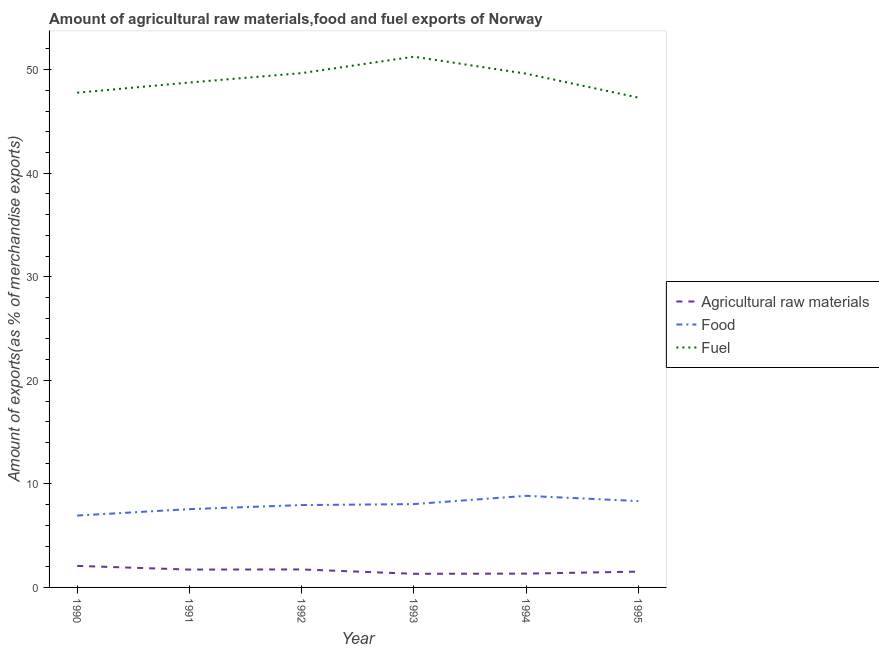Does the line corresponding to percentage of fuel exports intersect with the line corresponding to percentage of food exports?
Ensure brevity in your answer.  No. Is the number of lines equal to the number of legend labels?
Your response must be concise. Yes. What is the percentage of raw materials exports in 1991?
Your answer should be very brief. 1.72. Across all years, what is the maximum percentage of fuel exports?
Your answer should be very brief. 51.26. Across all years, what is the minimum percentage of food exports?
Offer a very short reply. 6.94. In which year was the percentage of food exports maximum?
Offer a terse response. 1994. What is the total percentage of fuel exports in the graph?
Ensure brevity in your answer.  294.38. What is the difference between the percentage of fuel exports in 1991 and that in 1994?
Ensure brevity in your answer.  -0.85. What is the difference between the percentage of food exports in 1990 and the percentage of fuel exports in 1994?
Offer a terse response. -42.67. What is the average percentage of raw materials exports per year?
Your answer should be very brief. 1.62. In the year 1993, what is the difference between the percentage of food exports and percentage of fuel exports?
Give a very brief answer. -43.21. In how many years, is the percentage of food exports greater than 20 %?
Your answer should be compact. 0. What is the ratio of the percentage of food exports in 1993 to that in 1995?
Provide a short and direct response. 0.96. What is the difference between the highest and the second highest percentage of food exports?
Your answer should be compact. 0.5. What is the difference between the highest and the lowest percentage of fuel exports?
Ensure brevity in your answer.  3.95. Is the percentage of food exports strictly greater than the percentage of fuel exports over the years?
Provide a succinct answer. No. Is the percentage of raw materials exports strictly less than the percentage of fuel exports over the years?
Provide a succinct answer. Yes. How many years are there in the graph?
Give a very brief answer. 6. Does the graph contain any zero values?
Give a very brief answer. No. Where does the legend appear in the graph?
Provide a short and direct response. Center right. How many legend labels are there?
Make the answer very short. 3. What is the title of the graph?
Give a very brief answer. Amount of agricultural raw materials,food and fuel exports of Norway. What is the label or title of the X-axis?
Your answer should be very brief. Year. What is the label or title of the Y-axis?
Provide a short and direct response. Amount of exports(as % of merchandise exports). What is the Amount of exports(as % of merchandise exports) in Agricultural raw materials in 1990?
Ensure brevity in your answer.  2.08. What is the Amount of exports(as % of merchandise exports) in Food in 1990?
Make the answer very short. 6.94. What is the Amount of exports(as % of merchandise exports) in Fuel in 1990?
Give a very brief answer. 47.78. What is the Amount of exports(as % of merchandise exports) in Agricultural raw materials in 1991?
Offer a very short reply. 1.72. What is the Amount of exports(as % of merchandise exports) in Food in 1991?
Your answer should be compact. 7.56. What is the Amount of exports(as % of merchandise exports) of Fuel in 1991?
Offer a terse response. 48.76. What is the Amount of exports(as % of merchandise exports) of Agricultural raw materials in 1992?
Your answer should be very brief. 1.74. What is the Amount of exports(as % of merchandise exports) in Food in 1992?
Provide a short and direct response. 7.95. What is the Amount of exports(as % of merchandise exports) in Fuel in 1992?
Provide a short and direct response. 49.67. What is the Amount of exports(as % of merchandise exports) in Agricultural raw materials in 1993?
Provide a short and direct response. 1.32. What is the Amount of exports(as % of merchandise exports) of Food in 1993?
Keep it short and to the point. 8.05. What is the Amount of exports(as % of merchandise exports) of Fuel in 1993?
Your answer should be compact. 51.26. What is the Amount of exports(as % of merchandise exports) in Agricultural raw materials in 1994?
Give a very brief answer. 1.33. What is the Amount of exports(as % of merchandise exports) in Food in 1994?
Provide a short and direct response. 8.85. What is the Amount of exports(as % of merchandise exports) of Fuel in 1994?
Offer a very short reply. 49.62. What is the Amount of exports(as % of merchandise exports) of Agricultural raw materials in 1995?
Offer a terse response. 1.53. What is the Amount of exports(as % of merchandise exports) of Food in 1995?
Provide a succinct answer. 8.34. What is the Amount of exports(as % of merchandise exports) of Fuel in 1995?
Offer a terse response. 47.3. Across all years, what is the maximum Amount of exports(as % of merchandise exports) of Agricultural raw materials?
Your response must be concise. 2.08. Across all years, what is the maximum Amount of exports(as % of merchandise exports) in Food?
Offer a terse response. 8.85. Across all years, what is the maximum Amount of exports(as % of merchandise exports) of Fuel?
Offer a terse response. 51.26. Across all years, what is the minimum Amount of exports(as % of merchandise exports) in Agricultural raw materials?
Ensure brevity in your answer.  1.32. Across all years, what is the minimum Amount of exports(as % of merchandise exports) of Food?
Offer a very short reply. 6.94. Across all years, what is the minimum Amount of exports(as % of merchandise exports) of Fuel?
Your answer should be compact. 47.3. What is the total Amount of exports(as % of merchandise exports) in Agricultural raw materials in the graph?
Offer a terse response. 9.72. What is the total Amount of exports(as % of merchandise exports) of Food in the graph?
Your response must be concise. 47.69. What is the total Amount of exports(as % of merchandise exports) of Fuel in the graph?
Make the answer very short. 294.38. What is the difference between the Amount of exports(as % of merchandise exports) of Agricultural raw materials in 1990 and that in 1991?
Keep it short and to the point. 0.36. What is the difference between the Amount of exports(as % of merchandise exports) of Food in 1990 and that in 1991?
Give a very brief answer. -0.62. What is the difference between the Amount of exports(as % of merchandise exports) of Fuel in 1990 and that in 1991?
Provide a succinct answer. -0.98. What is the difference between the Amount of exports(as % of merchandise exports) of Agricultural raw materials in 1990 and that in 1992?
Keep it short and to the point. 0.34. What is the difference between the Amount of exports(as % of merchandise exports) of Food in 1990 and that in 1992?
Your answer should be compact. -1.01. What is the difference between the Amount of exports(as % of merchandise exports) of Fuel in 1990 and that in 1992?
Your answer should be very brief. -1.89. What is the difference between the Amount of exports(as % of merchandise exports) of Agricultural raw materials in 1990 and that in 1993?
Provide a succinct answer. 0.76. What is the difference between the Amount of exports(as % of merchandise exports) in Food in 1990 and that in 1993?
Offer a terse response. -1.1. What is the difference between the Amount of exports(as % of merchandise exports) in Fuel in 1990 and that in 1993?
Your answer should be very brief. -3.48. What is the difference between the Amount of exports(as % of merchandise exports) of Agricultural raw materials in 1990 and that in 1994?
Offer a very short reply. 0.75. What is the difference between the Amount of exports(as % of merchandise exports) in Food in 1990 and that in 1994?
Offer a very short reply. -1.9. What is the difference between the Amount of exports(as % of merchandise exports) of Fuel in 1990 and that in 1994?
Keep it short and to the point. -1.84. What is the difference between the Amount of exports(as % of merchandise exports) of Agricultural raw materials in 1990 and that in 1995?
Offer a very short reply. 0.55. What is the difference between the Amount of exports(as % of merchandise exports) in Food in 1990 and that in 1995?
Make the answer very short. -1.4. What is the difference between the Amount of exports(as % of merchandise exports) of Fuel in 1990 and that in 1995?
Keep it short and to the point. 0.47. What is the difference between the Amount of exports(as % of merchandise exports) in Agricultural raw materials in 1991 and that in 1992?
Make the answer very short. -0.01. What is the difference between the Amount of exports(as % of merchandise exports) in Food in 1991 and that in 1992?
Make the answer very short. -0.39. What is the difference between the Amount of exports(as % of merchandise exports) in Fuel in 1991 and that in 1992?
Your response must be concise. -0.91. What is the difference between the Amount of exports(as % of merchandise exports) of Agricultural raw materials in 1991 and that in 1993?
Your response must be concise. 0.41. What is the difference between the Amount of exports(as % of merchandise exports) of Food in 1991 and that in 1993?
Offer a terse response. -0.49. What is the difference between the Amount of exports(as % of merchandise exports) in Fuel in 1991 and that in 1993?
Provide a succinct answer. -2.5. What is the difference between the Amount of exports(as % of merchandise exports) of Agricultural raw materials in 1991 and that in 1994?
Keep it short and to the point. 0.39. What is the difference between the Amount of exports(as % of merchandise exports) in Food in 1991 and that in 1994?
Your response must be concise. -1.28. What is the difference between the Amount of exports(as % of merchandise exports) in Fuel in 1991 and that in 1994?
Offer a very short reply. -0.85. What is the difference between the Amount of exports(as % of merchandise exports) of Agricultural raw materials in 1991 and that in 1995?
Ensure brevity in your answer.  0.2. What is the difference between the Amount of exports(as % of merchandise exports) in Food in 1991 and that in 1995?
Offer a very short reply. -0.78. What is the difference between the Amount of exports(as % of merchandise exports) in Fuel in 1991 and that in 1995?
Your answer should be compact. 1.46. What is the difference between the Amount of exports(as % of merchandise exports) in Agricultural raw materials in 1992 and that in 1993?
Provide a short and direct response. 0.42. What is the difference between the Amount of exports(as % of merchandise exports) of Food in 1992 and that in 1993?
Your response must be concise. -0.1. What is the difference between the Amount of exports(as % of merchandise exports) of Fuel in 1992 and that in 1993?
Make the answer very short. -1.59. What is the difference between the Amount of exports(as % of merchandise exports) in Agricultural raw materials in 1992 and that in 1994?
Keep it short and to the point. 0.4. What is the difference between the Amount of exports(as % of merchandise exports) of Food in 1992 and that in 1994?
Ensure brevity in your answer.  -0.89. What is the difference between the Amount of exports(as % of merchandise exports) of Fuel in 1992 and that in 1994?
Keep it short and to the point. 0.05. What is the difference between the Amount of exports(as % of merchandise exports) of Agricultural raw materials in 1992 and that in 1995?
Offer a very short reply. 0.21. What is the difference between the Amount of exports(as % of merchandise exports) of Food in 1992 and that in 1995?
Provide a short and direct response. -0.39. What is the difference between the Amount of exports(as % of merchandise exports) in Fuel in 1992 and that in 1995?
Offer a very short reply. 2.36. What is the difference between the Amount of exports(as % of merchandise exports) of Agricultural raw materials in 1993 and that in 1994?
Make the answer very short. -0.02. What is the difference between the Amount of exports(as % of merchandise exports) of Food in 1993 and that in 1994?
Your answer should be compact. -0.8. What is the difference between the Amount of exports(as % of merchandise exports) in Fuel in 1993 and that in 1994?
Give a very brief answer. 1.64. What is the difference between the Amount of exports(as % of merchandise exports) in Agricultural raw materials in 1993 and that in 1995?
Ensure brevity in your answer.  -0.21. What is the difference between the Amount of exports(as % of merchandise exports) of Food in 1993 and that in 1995?
Provide a short and direct response. -0.29. What is the difference between the Amount of exports(as % of merchandise exports) of Fuel in 1993 and that in 1995?
Offer a terse response. 3.95. What is the difference between the Amount of exports(as % of merchandise exports) in Agricultural raw materials in 1994 and that in 1995?
Give a very brief answer. -0.19. What is the difference between the Amount of exports(as % of merchandise exports) in Food in 1994 and that in 1995?
Ensure brevity in your answer.  0.5. What is the difference between the Amount of exports(as % of merchandise exports) in Fuel in 1994 and that in 1995?
Your answer should be compact. 2.31. What is the difference between the Amount of exports(as % of merchandise exports) in Agricultural raw materials in 1990 and the Amount of exports(as % of merchandise exports) in Food in 1991?
Your answer should be very brief. -5.48. What is the difference between the Amount of exports(as % of merchandise exports) in Agricultural raw materials in 1990 and the Amount of exports(as % of merchandise exports) in Fuel in 1991?
Provide a succinct answer. -46.68. What is the difference between the Amount of exports(as % of merchandise exports) of Food in 1990 and the Amount of exports(as % of merchandise exports) of Fuel in 1991?
Your answer should be very brief. -41.82. What is the difference between the Amount of exports(as % of merchandise exports) in Agricultural raw materials in 1990 and the Amount of exports(as % of merchandise exports) in Food in 1992?
Your answer should be compact. -5.87. What is the difference between the Amount of exports(as % of merchandise exports) in Agricultural raw materials in 1990 and the Amount of exports(as % of merchandise exports) in Fuel in 1992?
Your answer should be very brief. -47.59. What is the difference between the Amount of exports(as % of merchandise exports) in Food in 1990 and the Amount of exports(as % of merchandise exports) in Fuel in 1992?
Keep it short and to the point. -42.73. What is the difference between the Amount of exports(as % of merchandise exports) of Agricultural raw materials in 1990 and the Amount of exports(as % of merchandise exports) of Food in 1993?
Offer a very short reply. -5.97. What is the difference between the Amount of exports(as % of merchandise exports) of Agricultural raw materials in 1990 and the Amount of exports(as % of merchandise exports) of Fuel in 1993?
Keep it short and to the point. -49.18. What is the difference between the Amount of exports(as % of merchandise exports) of Food in 1990 and the Amount of exports(as % of merchandise exports) of Fuel in 1993?
Give a very brief answer. -44.31. What is the difference between the Amount of exports(as % of merchandise exports) in Agricultural raw materials in 1990 and the Amount of exports(as % of merchandise exports) in Food in 1994?
Offer a terse response. -6.77. What is the difference between the Amount of exports(as % of merchandise exports) in Agricultural raw materials in 1990 and the Amount of exports(as % of merchandise exports) in Fuel in 1994?
Keep it short and to the point. -47.54. What is the difference between the Amount of exports(as % of merchandise exports) in Food in 1990 and the Amount of exports(as % of merchandise exports) in Fuel in 1994?
Provide a succinct answer. -42.67. What is the difference between the Amount of exports(as % of merchandise exports) of Agricultural raw materials in 1990 and the Amount of exports(as % of merchandise exports) of Food in 1995?
Your response must be concise. -6.26. What is the difference between the Amount of exports(as % of merchandise exports) of Agricultural raw materials in 1990 and the Amount of exports(as % of merchandise exports) of Fuel in 1995?
Offer a terse response. -45.22. What is the difference between the Amount of exports(as % of merchandise exports) of Food in 1990 and the Amount of exports(as % of merchandise exports) of Fuel in 1995?
Your answer should be compact. -40.36. What is the difference between the Amount of exports(as % of merchandise exports) of Agricultural raw materials in 1991 and the Amount of exports(as % of merchandise exports) of Food in 1992?
Make the answer very short. -6.23. What is the difference between the Amount of exports(as % of merchandise exports) of Agricultural raw materials in 1991 and the Amount of exports(as % of merchandise exports) of Fuel in 1992?
Provide a short and direct response. -47.95. What is the difference between the Amount of exports(as % of merchandise exports) of Food in 1991 and the Amount of exports(as % of merchandise exports) of Fuel in 1992?
Keep it short and to the point. -42.11. What is the difference between the Amount of exports(as % of merchandise exports) of Agricultural raw materials in 1991 and the Amount of exports(as % of merchandise exports) of Food in 1993?
Provide a succinct answer. -6.32. What is the difference between the Amount of exports(as % of merchandise exports) in Agricultural raw materials in 1991 and the Amount of exports(as % of merchandise exports) in Fuel in 1993?
Provide a short and direct response. -49.53. What is the difference between the Amount of exports(as % of merchandise exports) of Food in 1991 and the Amount of exports(as % of merchandise exports) of Fuel in 1993?
Offer a very short reply. -43.69. What is the difference between the Amount of exports(as % of merchandise exports) of Agricultural raw materials in 1991 and the Amount of exports(as % of merchandise exports) of Food in 1994?
Your answer should be very brief. -7.12. What is the difference between the Amount of exports(as % of merchandise exports) of Agricultural raw materials in 1991 and the Amount of exports(as % of merchandise exports) of Fuel in 1994?
Ensure brevity in your answer.  -47.89. What is the difference between the Amount of exports(as % of merchandise exports) of Food in 1991 and the Amount of exports(as % of merchandise exports) of Fuel in 1994?
Your answer should be compact. -42.05. What is the difference between the Amount of exports(as % of merchandise exports) in Agricultural raw materials in 1991 and the Amount of exports(as % of merchandise exports) in Food in 1995?
Make the answer very short. -6.62. What is the difference between the Amount of exports(as % of merchandise exports) in Agricultural raw materials in 1991 and the Amount of exports(as % of merchandise exports) in Fuel in 1995?
Provide a short and direct response. -45.58. What is the difference between the Amount of exports(as % of merchandise exports) of Food in 1991 and the Amount of exports(as % of merchandise exports) of Fuel in 1995?
Provide a short and direct response. -39.74. What is the difference between the Amount of exports(as % of merchandise exports) in Agricultural raw materials in 1992 and the Amount of exports(as % of merchandise exports) in Food in 1993?
Keep it short and to the point. -6.31. What is the difference between the Amount of exports(as % of merchandise exports) of Agricultural raw materials in 1992 and the Amount of exports(as % of merchandise exports) of Fuel in 1993?
Your answer should be very brief. -49.52. What is the difference between the Amount of exports(as % of merchandise exports) of Food in 1992 and the Amount of exports(as % of merchandise exports) of Fuel in 1993?
Your answer should be very brief. -43.3. What is the difference between the Amount of exports(as % of merchandise exports) of Agricultural raw materials in 1992 and the Amount of exports(as % of merchandise exports) of Food in 1994?
Offer a very short reply. -7.11. What is the difference between the Amount of exports(as % of merchandise exports) in Agricultural raw materials in 1992 and the Amount of exports(as % of merchandise exports) in Fuel in 1994?
Offer a terse response. -47.88. What is the difference between the Amount of exports(as % of merchandise exports) of Food in 1992 and the Amount of exports(as % of merchandise exports) of Fuel in 1994?
Offer a very short reply. -41.66. What is the difference between the Amount of exports(as % of merchandise exports) in Agricultural raw materials in 1992 and the Amount of exports(as % of merchandise exports) in Food in 1995?
Provide a succinct answer. -6.6. What is the difference between the Amount of exports(as % of merchandise exports) in Agricultural raw materials in 1992 and the Amount of exports(as % of merchandise exports) in Fuel in 1995?
Your answer should be very brief. -45.57. What is the difference between the Amount of exports(as % of merchandise exports) in Food in 1992 and the Amount of exports(as % of merchandise exports) in Fuel in 1995?
Give a very brief answer. -39.35. What is the difference between the Amount of exports(as % of merchandise exports) of Agricultural raw materials in 1993 and the Amount of exports(as % of merchandise exports) of Food in 1994?
Your response must be concise. -7.53. What is the difference between the Amount of exports(as % of merchandise exports) in Agricultural raw materials in 1993 and the Amount of exports(as % of merchandise exports) in Fuel in 1994?
Provide a short and direct response. -48.3. What is the difference between the Amount of exports(as % of merchandise exports) in Food in 1993 and the Amount of exports(as % of merchandise exports) in Fuel in 1994?
Make the answer very short. -41.57. What is the difference between the Amount of exports(as % of merchandise exports) in Agricultural raw materials in 1993 and the Amount of exports(as % of merchandise exports) in Food in 1995?
Your answer should be compact. -7.03. What is the difference between the Amount of exports(as % of merchandise exports) of Agricultural raw materials in 1993 and the Amount of exports(as % of merchandise exports) of Fuel in 1995?
Give a very brief answer. -45.99. What is the difference between the Amount of exports(as % of merchandise exports) in Food in 1993 and the Amount of exports(as % of merchandise exports) in Fuel in 1995?
Offer a terse response. -39.26. What is the difference between the Amount of exports(as % of merchandise exports) in Agricultural raw materials in 1994 and the Amount of exports(as % of merchandise exports) in Food in 1995?
Offer a very short reply. -7.01. What is the difference between the Amount of exports(as % of merchandise exports) in Agricultural raw materials in 1994 and the Amount of exports(as % of merchandise exports) in Fuel in 1995?
Keep it short and to the point. -45.97. What is the difference between the Amount of exports(as % of merchandise exports) in Food in 1994 and the Amount of exports(as % of merchandise exports) in Fuel in 1995?
Your response must be concise. -38.46. What is the average Amount of exports(as % of merchandise exports) of Agricultural raw materials per year?
Your response must be concise. 1.62. What is the average Amount of exports(as % of merchandise exports) in Food per year?
Your answer should be compact. 7.95. What is the average Amount of exports(as % of merchandise exports) in Fuel per year?
Your response must be concise. 49.06. In the year 1990, what is the difference between the Amount of exports(as % of merchandise exports) in Agricultural raw materials and Amount of exports(as % of merchandise exports) in Food?
Make the answer very short. -4.86. In the year 1990, what is the difference between the Amount of exports(as % of merchandise exports) in Agricultural raw materials and Amount of exports(as % of merchandise exports) in Fuel?
Ensure brevity in your answer.  -45.7. In the year 1990, what is the difference between the Amount of exports(as % of merchandise exports) of Food and Amount of exports(as % of merchandise exports) of Fuel?
Your answer should be very brief. -40.83. In the year 1991, what is the difference between the Amount of exports(as % of merchandise exports) in Agricultural raw materials and Amount of exports(as % of merchandise exports) in Food?
Keep it short and to the point. -5.84. In the year 1991, what is the difference between the Amount of exports(as % of merchandise exports) of Agricultural raw materials and Amount of exports(as % of merchandise exports) of Fuel?
Offer a very short reply. -47.04. In the year 1991, what is the difference between the Amount of exports(as % of merchandise exports) in Food and Amount of exports(as % of merchandise exports) in Fuel?
Offer a very short reply. -41.2. In the year 1992, what is the difference between the Amount of exports(as % of merchandise exports) in Agricultural raw materials and Amount of exports(as % of merchandise exports) in Food?
Give a very brief answer. -6.21. In the year 1992, what is the difference between the Amount of exports(as % of merchandise exports) of Agricultural raw materials and Amount of exports(as % of merchandise exports) of Fuel?
Ensure brevity in your answer.  -47.93. In the year 1992, what is the difference between the Amount of exports(as % of merchandise exports) of Food and Amount of exports(as % of merchandise exports) of Fuel?
Give a very brief answer. -41.72. In the year 1993, what is the difference between the Amount of exports(as % of merchandise exports) in Agricultural raw materials and Amount of exports(as % of merchandise exports) in Food?
Ensure brevity in your answer.  -6.73. In the year 1993, what is the difference between the Amount of exports(as % of merchandise exports) of Agricultural raw materials and Amount of exports(as % of merchandise exports) of Fuel?
Your answer should be compact. -49.94. In the year 1993, what is the difference between the Amount of exports(as % of merchandise exports) of Food and Amount of exports(as % of merchandise exports) of Fuel?
Your answer should be compact. -43.21. In the year 1994, what is the difference between the Amount of exports(as % of merchandise exports) of Agricultural raw materials and Amount of exports(as % of merchandise exports) of Food?
Keep it short and to the point. -7.51. In the year 1994, what is the difference between the Amount of exports(as % of merchandise exports) of Agricultural raw materials and Amount of exports(as % of merchandise exports) of Fuel?
Ensure brevity in your answer.  -48.28. In the year 1994, what is the difference between the Amount of exports(as % of merchandise exports) of Food and Amount of exports(as % of merchandise exports) of Fuel?
Keep it short and to the point. -40.77. In the year 1995, what is the difference between the Amount of exports(as % of merchandise exports) in Agricultural raw materials and Amount of exports(as % of merchandise exports) in Food?
Ensure brevity in your answer.  -6.81. In the year 1995, what is the difference between the Amount of exports(as % of merchandise exports) in Agricultural raw materials and Amount of exports(as % of merchandise exports) in Fuel?
Make the answer very short. -45.78. In the year 1995, what is the difference between the Amount of exports(as % of merchandise exports) of Food and Amount of exports(as % of merchandise exports) of Fuel?
Provide a short and direct response. -38.96. What is the ratio of the Amount of exports(as % of merchandise exports) of Agricultural raw materials in 1990 to that in 1991?
Provide a succinct answer. 1.21. What is the ratio of the Amount of exports(as % of merchandise exports) of Food in 1990 to that in 1991?
Offer a very short reply. 0.92. What is the ratio of the Amount of exports(as % of merchandise exports) in Fuel in 1990 to that in 1991?
Your response must be concise. 0.98. What is the ratio of the Amount of exports(as % of merchandise exports) of Agricultural raw materials in 1990 to that in 1992?
Ensure brevity in your answer.  1.2. What is the ratio of the Amount of exports(as % of merchandise exports) in Food in 1990 to that in 1992?
Keep it short and to the point. 0.87. What is the ratio of the Amount of exports(as % of merchandise exports) of Fuel in 1990 to that in 1992?
Keep it short and to the point. 0.96. What is the ratio of the Amount of exports(as % of merchandise exports) of Agricultural raw materials in 1990 to that in 1993?
Offer a very short reply. 1.58. What is the ratio of the Amount of exports(as % of merchandise exports) of Food in 1990 to that in 1993?
Offer a very short reply. 0.86. What is the ratio of the Amount of exports(as % of merchandise exports) of Fuel in 1990 to that in 1993?
Offer a terse response. 0.93. What is the ratio of the Amount of exports(as % of merchandise exports) of Agricultural raw materials in 1990 to that in 1994?
Your answer should be very brief. 1.56. What is the ratio of the Amount of exports(as % of merchandise exports) in Food in 1990 to that in 1994?
Offer a terse response. 0.78. What is the ratio of the Amount of exports(as % of merchandise exports) of Fuel in 1990 to that in 1994?
Keep it short and to the point. 0.96. What is the ratio of the Amount of exports(as % of merchandise exports) in Agricultural raw materials in 1990 to that in 1995?
Your answer should be very brief. 1.36. What is the ratio of the Amount of exports(as % of merchandise exports) in Food in 1990 to that in 1995?
Offer a terse response. 0.83. What is the ratio of the Amount of exports(as % of merchandise exports) of Fuel in 1990 to that in 1995?
Make the answer very short. 1.01. What is the ratio of the Amount of exports(as % of merchandise exports) of Agricultural raw materials in 1991 to that in 1992?
Provide a short and direct response. 0.99. What is the ratio of the Amount of exports(as % of merchandise exports) in Food in 1991 to that in 1992?
Keep it short and to the point. 0.95. What is the ratio of the Amount of exports(as % of merchandise exports) of Fuel in 1991 to that in 1992?
Offer a very short reply. 0.98. What is the ratio of the Amount of exports(as % of merchandise exports) in Agricultural raw materials in 1991 to that in 1993?
Provide a succinct answer. 1.31. What is the ratio of the Amount of exports(as % of merchandise exports) in Food in 1991 to that in 1993?
Your response must be concise. 0.94. What is the ratio of the Amount of exports(as % of merchandise exports) in Fuel in 1991 to that in 1993?
Provide a succinct answer. 0.95. What is the ratio of the Amount of exports(as % of merchandise exports) in Agricultural raw materials in 1991 to that in 1994?
Keep it short and to the point. 1.29. What is the ratio of the Amount of exports(as % of merchandise exports) of Food in 1991 to that in 1994?
Provide a succinct answer. 0.85. What is the ratio of the Amount of exports(as % of merchandise exports) in Fuel in 1991 to that in 1994?
Give a very brief answer. 0.98. What is the ratio of the Amount of exports(as % of merchandise exports) of Agricultural raw materials in 1991 to that in 1995?
Give a very brief answer. 1.13. What is the ratio of the Amount of exports(as % of merchandise exports) in Food in 1991 to that in 1995?
Your response must be concise. 0.91. What is the ratio of the Amount of exports(as % of merchandise exports) in Fuel in 1991 to that in 1995?
Ensure brevity in your answer.  1.03. What is the ratio of the Amount of exports(as % of merchandise exports) in Agricultural raw materials in 1992 to that in 1993?
Your answer should be very brief. 1.32. What is the ratio of the Amount of exports(as % of merchandise exports) in Fuel in 1992 to that in 1993?
Make the answer very short. 0.97. What is the ratio of the Amount of exports(as % of merchandise exports) in Agricultural raw materials in 1992 to that in 1994?
Provide a succinct answer. 1.3. What is the ratio of the Amount of exports(as % of merchandise exports) in Food in 1992 to that in 1994?
Your answer should be very brief. 0.9. What is the ratio of the Amount of exports(as % of merchandise exports) of Agricultural raw materials in 1992 to that in 1995?
Your response must be concise. 1.14. What is the ratio of the Amount of exports(as % of merchandise exports) of Food in 1992 to that in 1995?
Offer a terse response. 0.95. What is the ratio of the Amount of exports(as % of merchandise exports) in Agricultural raw materials in 1993 to that in 1994?
Ensure brevity in your answer.  0.99. What is the ratio of the Amount of exports(as % of merchandise exports) in Food in 1993 to that in 1994?
Keep it short and to the point. 0.91. What is the ratio of the Amount of exports(as % of merchandise exports) of Fuel in 1993 to that in 1994?
Offer a terse response. 1.03. What is the ratio of the Amount of exports(as % of merchandise exports) of Agricultural raw materials in 1993 to that in 1995?
Offer a terse response. 0.86. What is the ratio of the Amount of exports(as % of merchandise exports) of Food in 1993 to that in 1995?
Your answer should be very brief. 0.96. What is the ratio of the Amount of exports(as % of merchandise exports) in Fuel in 1993 to that in 1995?
Your answer should be compact. 1.08. What is the ratio of the Amount of exports(as % of merchandise exports) of Agricultural raw materials in 1994 to that in 1995?
Provide a succinct answer. 0.87. What is the ratio of the Amount of exports(as % of merchandise exports) in Food in 1994 to that in 1995?
Your answer should be compact. 1.06. What is the ratio of the Amount of exports(as % of merchandise exports) of Fuel in 1994 to that in 1995?
Give a very brief answer. 1.05. What is the difference between the highest and the second highest Amount of exports(as % of merchandise exports) in Agricultural raw materials?
Make the answer very short. 0.34. What is the difference between the highest and the second highest Amount of exports(as % of merchandise exports) in Food?
Your answer should be compact. 0.5. What is the difference between the highest and the second highest Amount of exports(as % of merchandise exports) in Fuel?
Keep it short and to the point. 1.59. What is the difference between the highest and the lowest Amount of exports(as % of merchandise exports) in Agricultural raw materials?
Make the answer very short. 0.76. What is the difference between the highest and the lowest Amount of exports(as % of merchandise exports) in Food?
Keep it short and to the point. 1.9. What is the difference between the highest and the lowest Amount of exports(as % of merchandise exports) in Fuel?
Make the answer very short. 3.95. 